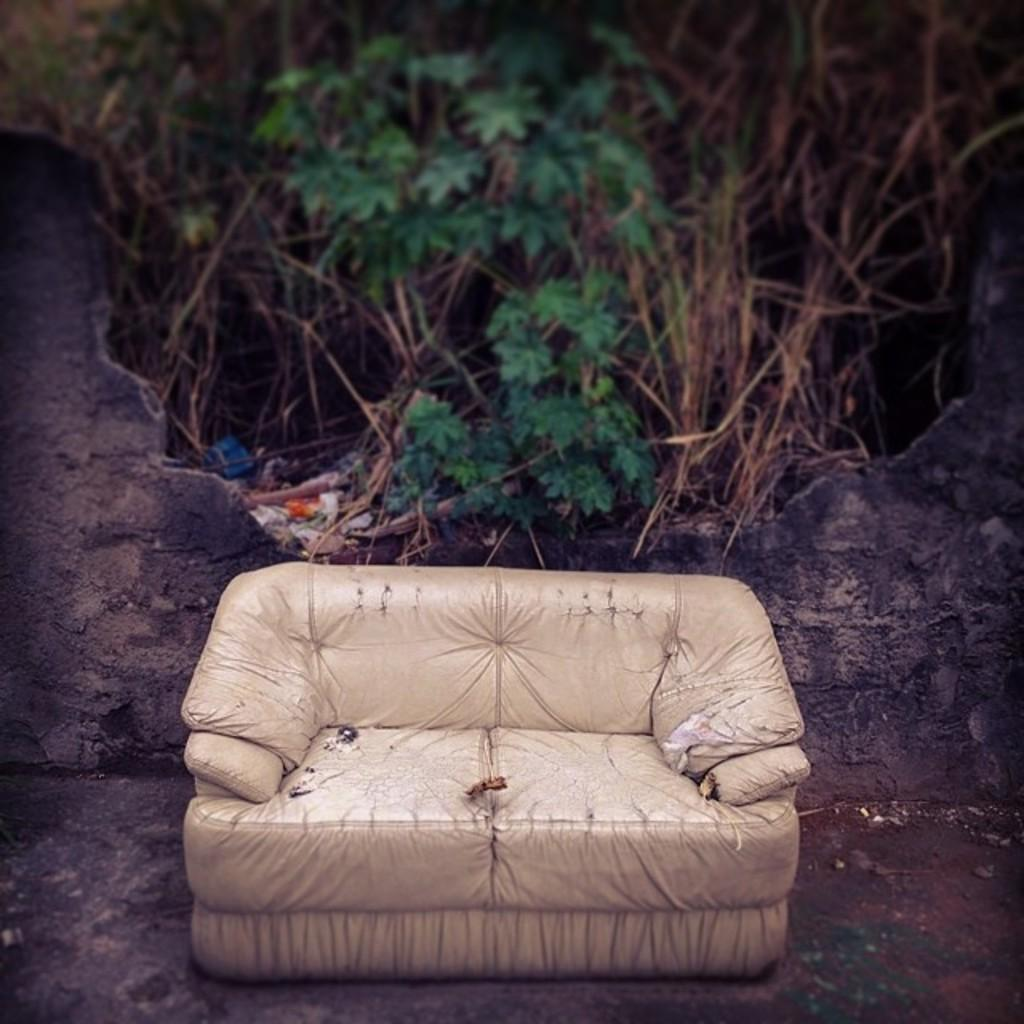What is the main piece of furniture in the front of the image? There is a couch in the front of the image. What can be seen in the background of the image? There are trees and leaves in the background of the image. What type of waste is visible in the image? There is some garbage visible in the image. What is on the left side of the image? There is a wall on the left side of the image. What flavor of ice cream is being enjoyed by the person sitting on the couch in the image? There is no person sitting on the couch in the image, nor is there any ice cream present. 